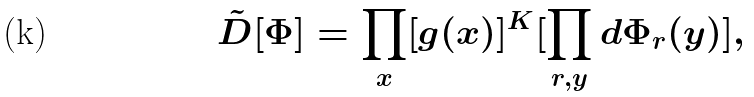<formula> <loc_0><loc_0><loc_500><loc_500>\tilde { D } [ \Phi ] = \prod _ { x } [ g ( x ) ] ^ { K } [ \prod _ { r , y } d \Phi _ { r } ( y ) ] ,</formula> 